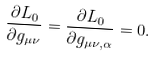Convert formula to latex. <formula><loc_0><loc_0><loc_500><loc_500>\frac { \partial L _ { 0 } } { \partial g _ { \mu \nu } } = \frac { \partial L _ { 0 } } { \partial g _ { \mu \nu , \alpha } } = 0 .</formula> 